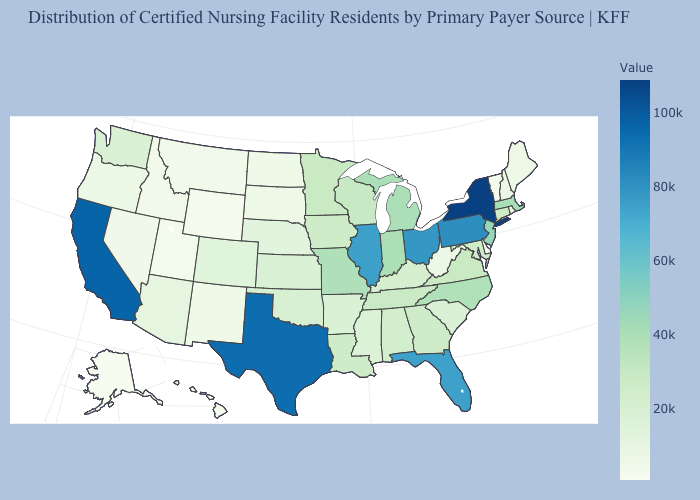Among the states that border Montana , does South Dakota have the lowest value?
Write a very short answer. No. Does Virginia have a higher value than Maine?
Write a very short answer. Yes. Which states hav the highest value in the Northeast?
Write a very short answer. New York. Which states have the highest value in the USA?
Give a very brief answer. New York. Does South Carolina have a lower value than Delaware?
Be succinct. No. Which states have the lowest value in the USA?
Short answer required. Alaska. Among the states that border Kansas , does Oklahoma have the lowest value?
Give a very brief answer. No. 